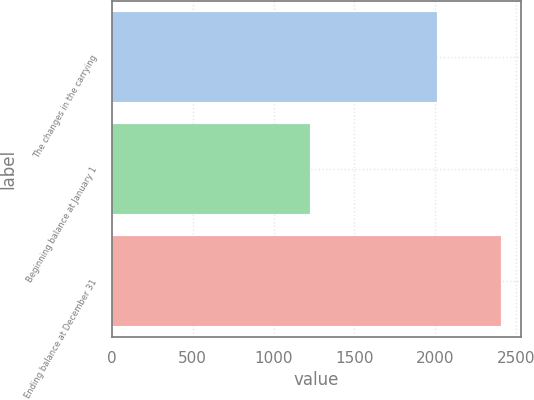<chart> <loc_0><loc_0><loc_500><loc_500><bar_chart><fcel>The changes in the carrying<fcel>Beginning balance at January 1<fcel>Ending balance at December 31<nl><fcel>2010<fcel>1225<fcel>2408<nl></chart> 